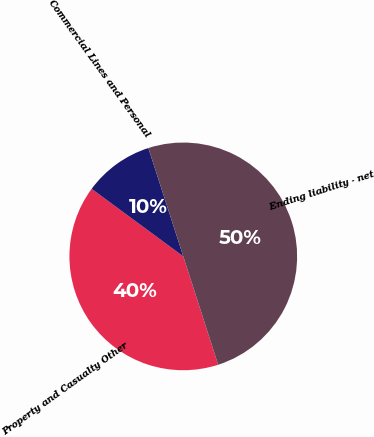Convert chart to OTSL. <chart><loc_0><loc_0><loc_500><loc_500><pie_chart><fcel>Property and Casualty Other<fcel>Commercial Lines and Personal<fcel>Ending liability - net<nl><fcel>40.07%<fcel>9.93%<fcel>50.0%<nl></chart> 